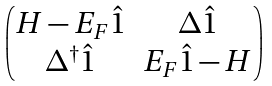<formula> <loc_0><loc_0><loc_500><loc_500>\begin{pmatrix} H - E _ { F } \hat { 1 } & \Delta \hat { 1 } \\ \Delta ^ { \dag } \hat { 1 } & E _ { F } \hat { 1 } - H \\ \end{pmatrix}</formula> 